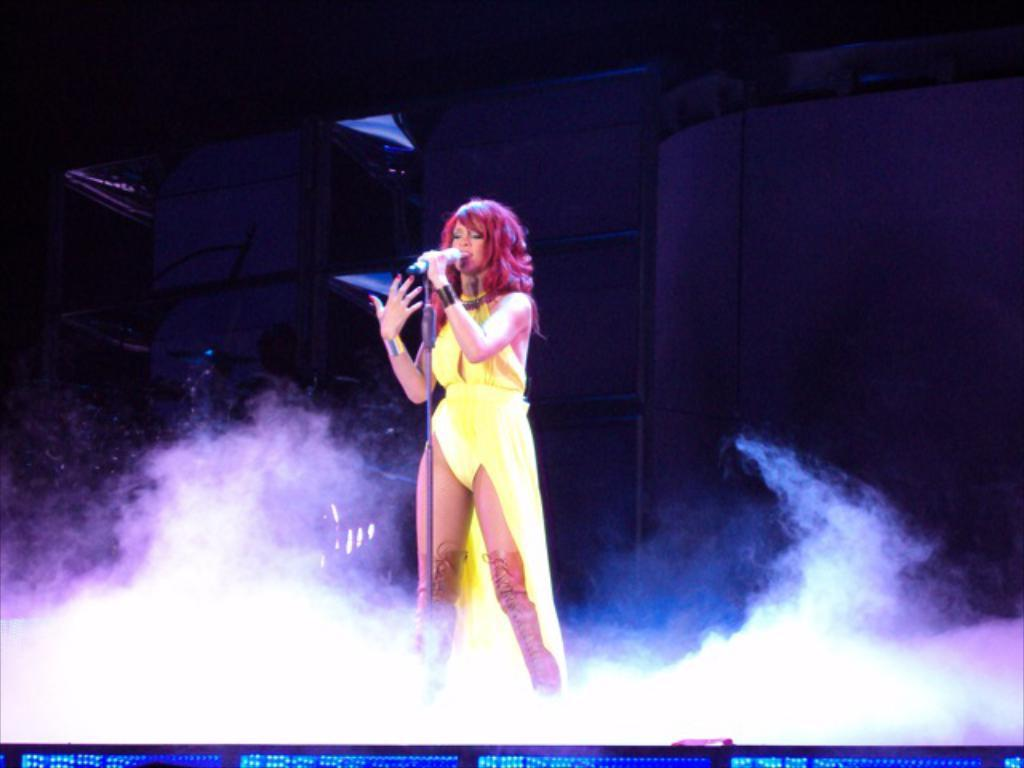Who is the main subject in the image? There is a lady in the image. What is the lady holding in the image? The lady is holding a microphone. What other object related to the microphone can be seen in the image? There is a microphone stand in the image. What can be seen at the bottom of the image? There is smoke at the bottom of the image. What is visible in the background of the image? There is a wall in the background of the image, and the background is dark. How many roses are on the wall in the image? There are no roses visible on the wall in the image. What type of cub is playing with the microphone in the image? There is no cub present in the image, and the lady is the one holding the microphone. 